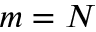<formula> <loc_0><loc_0><loc_500><loc_500>m = N</formula> 